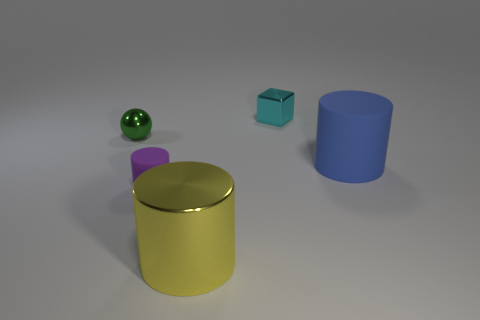Add 5 metallic cylinders. How many objects exist? 10 Subtract all cylinders. How many objects are left? 2 Subtract all yellow metallic spheres. Subtract all tiny green metal objects. How many objects are left? 4 Add 1 green metallic spheres. How many green metallic spheres are left? 2 Add 1 small red metal cylinders. How many small red metal cylinders exist? 1 Subtract 0 red spheres. How many objects are left? 5 